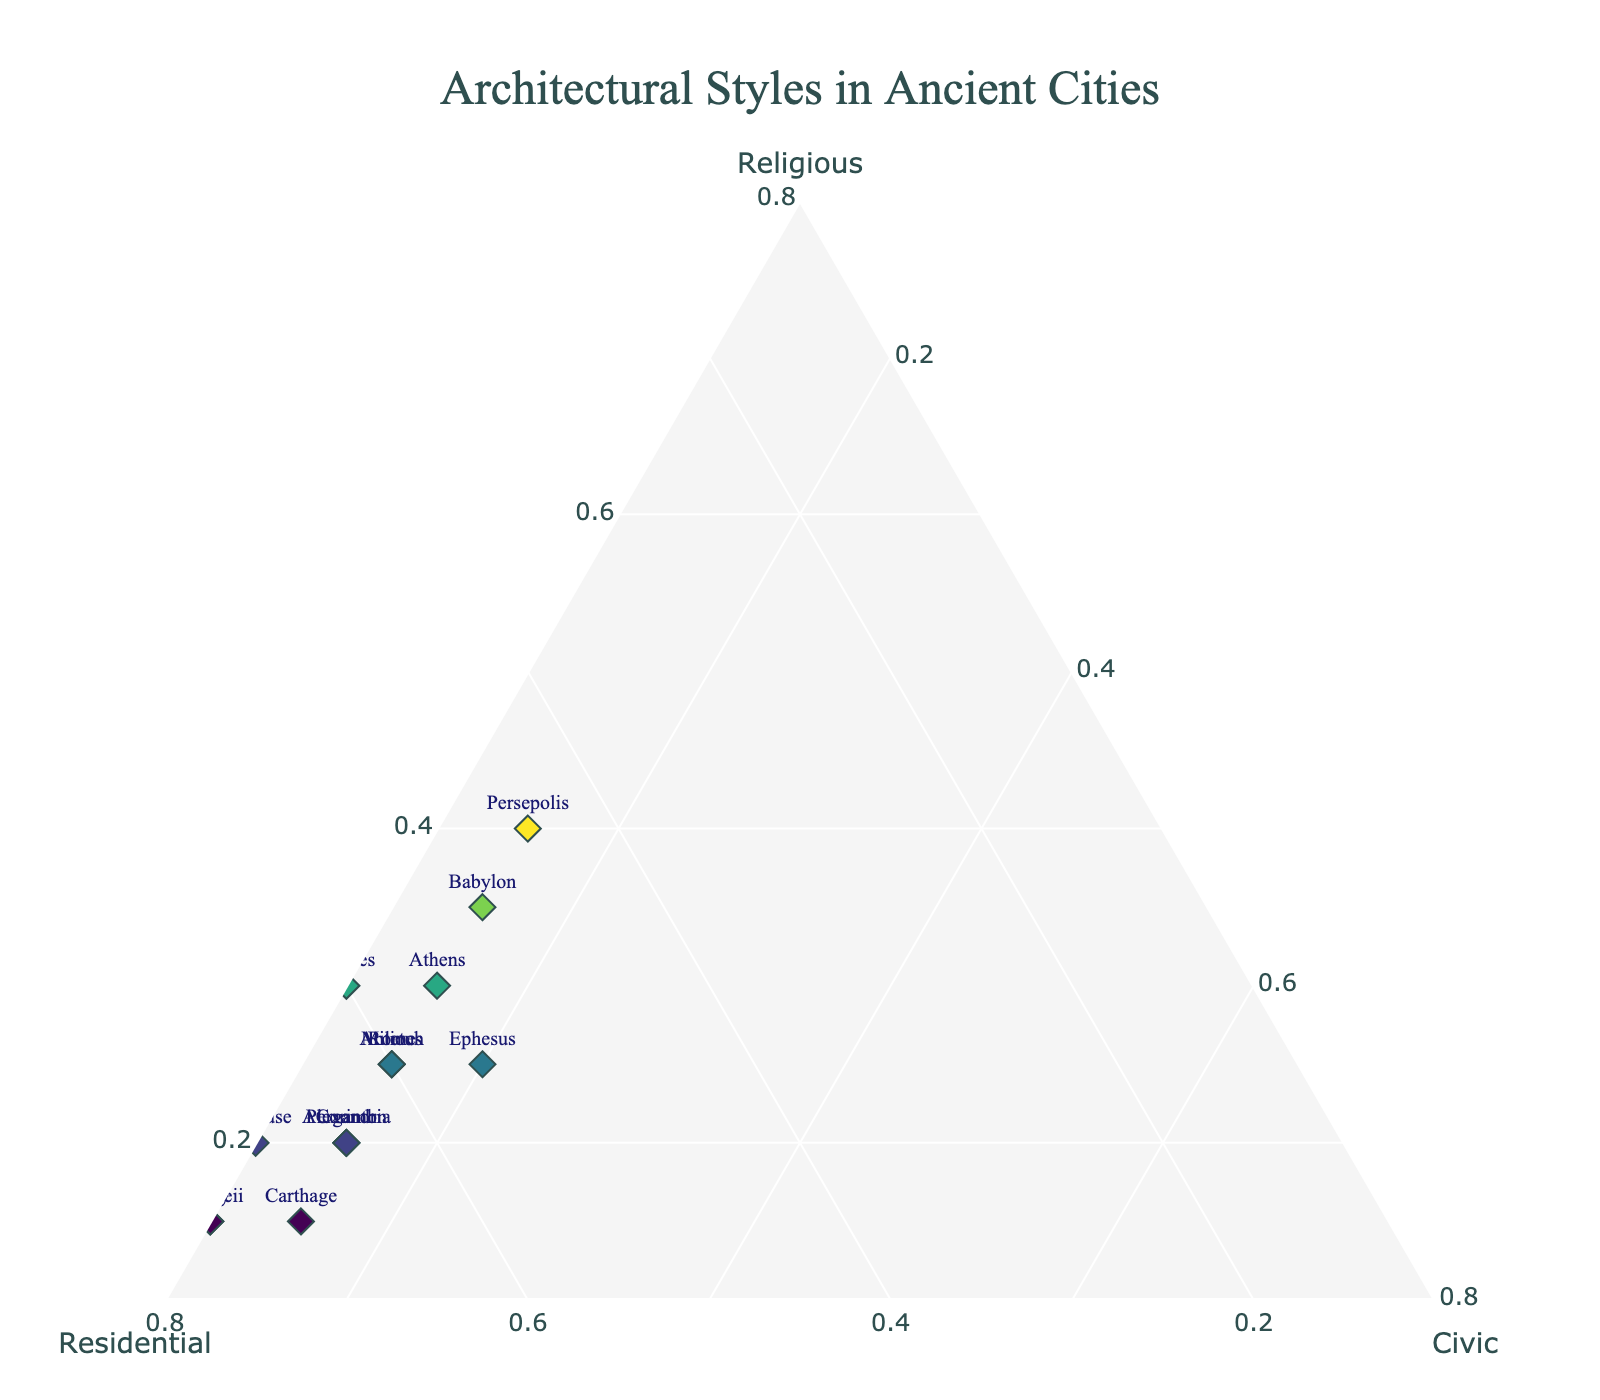What's the title of the figure? The title is prominently displayed at the top of the figure.
Answer: Architectural Styles in Ancient Cities How many cities have 70% or more Residential structures? By examining the data points along the Residential axis, we see that Carthage, Syracuse, and Pompeii have percentages that meet this criterion.
Answer: 3 Which city has the highest proportion of Religious structures? By comparing all the values along the Religious axis, the city with the highest proportion can be identified. Persepolis, with the highest 'A' (Religious) value at 40%.
Answer: Persepolis What are the proportions of Civic structures across all cities? The 'Civic' axis remains constant with a value of 15% for almost all cities except for Thebes, Troy, Syracuse, and Pompeii, where it is either 10% or 20%.
Answer: Mostly 15%, exceptions are Thebes, Troy, Syracuse, and Pompeii Which city has the smallest proportion of Civic structures? By locating the point closest to the apex for the other two categories, the city with the smallest Civic proportion (10%) is identified as being among Thebes, Troy, Syracuse, and Pompeii. All four have 10%.
Answer: Thebes, Troy, Syracuse, Pompeii Among Athens, Rome, and Alexandria, which city has the highest percentage of Residential structures? Comparing the Residential proportions from the three cities shows Alexandria with the highest at 65%.
Answer: Alexandria Calculate the average percentage of Religious structures among Persepolis, Athens, and Rome. First, sum the Religious proportions (40 + 30 + 25 = 95) and then divide by 3. 95/3 = 31.67%.
Answer: 31.67% What is the color theme used in the data points on the plot? The data points are color-coded using the 'Viridis' colorscale, which ranges from dark to light colors based on the value of Religious structures.
Answer: Viridis If a city has 60% Residential and 15% Civic structures, which cities could it be? By identifying the cities that meet both the Residential (60%) and Civic (15%) criteria, possible candidates are Rome, Antioch, and Miletus.
Answer: Rome, Antioch, Miletus Are there any cities with proportional representations of Civic structures greater than 15%? Looking at the Civic axis, we identify that Ephesus is the only city with a Civic structure proportional value of 20%.
Answer: Ephesus 